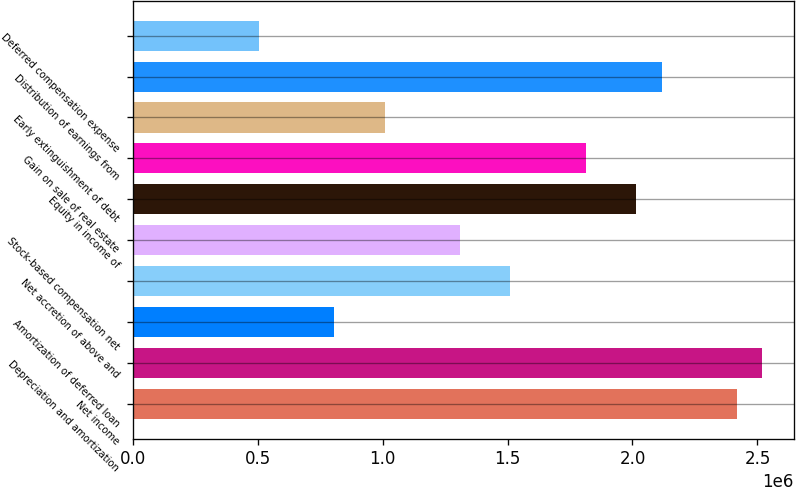Convert chart. <chart><loc_0><loc_0><loc_500><loc_500><bar_chart><fcel>Net income<fcel>Depreciation and amortization<fcel>Amortization of deferred loan<fcel>Net accretion of above and<fcel>Stock-based compensation net<fcel>Equity in income of<fcel>Gain on sale of real estate<fcel>Early extinguishment of debt<fcel>Distribution of earnings from<fcel>Deferred compensation expense<nl><fcel>2.41864e+06<fcel>2.5194e+06<fcel>806457<fcel>1.51179e+06<fcel>1.31026e+06<fcel>2.0156e+06<fcel>1.81407e+06<fcel>1.00798e+06<fcel>2.11636e+06<fcel>504172<nl></chart> 